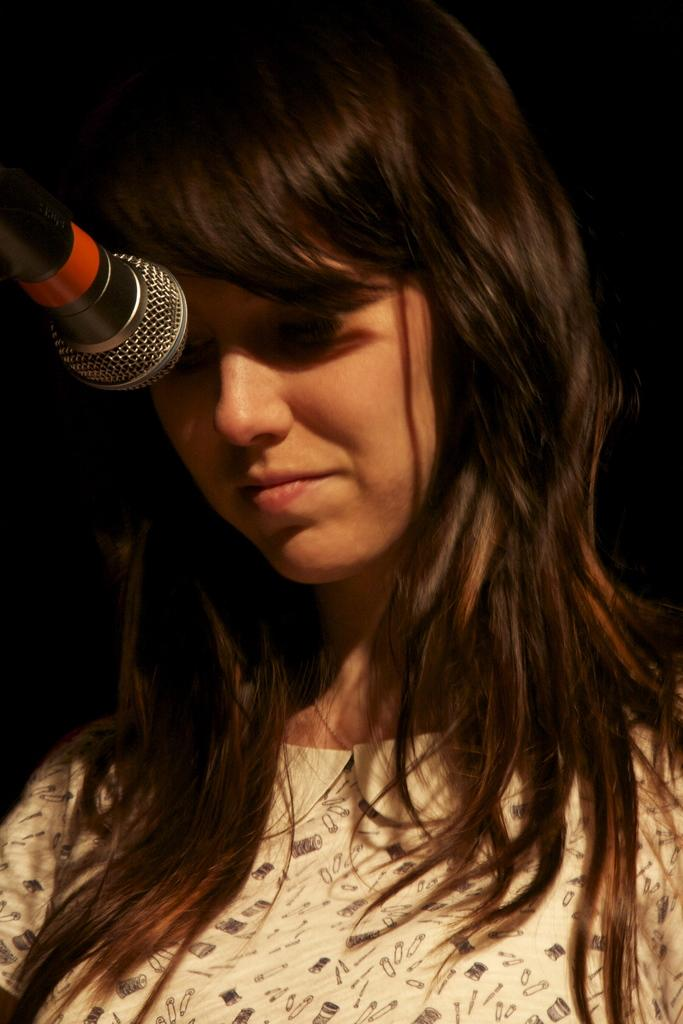What is the main subject of the image? The main subject of the image is a woman. What is the woman doing in the image? The woman is standing in the image. What object is in front of the woman? There is a microphone in front of the woman. What type of discovery did the woman make in the image? There is no indication in the image of a discovery made by the woman. What type of egg is visible in the image? There is no egg present in the image. What type of trousers is the woman wearing in the image? The provided facts do not mention the type of trousers the woman is wearing. 